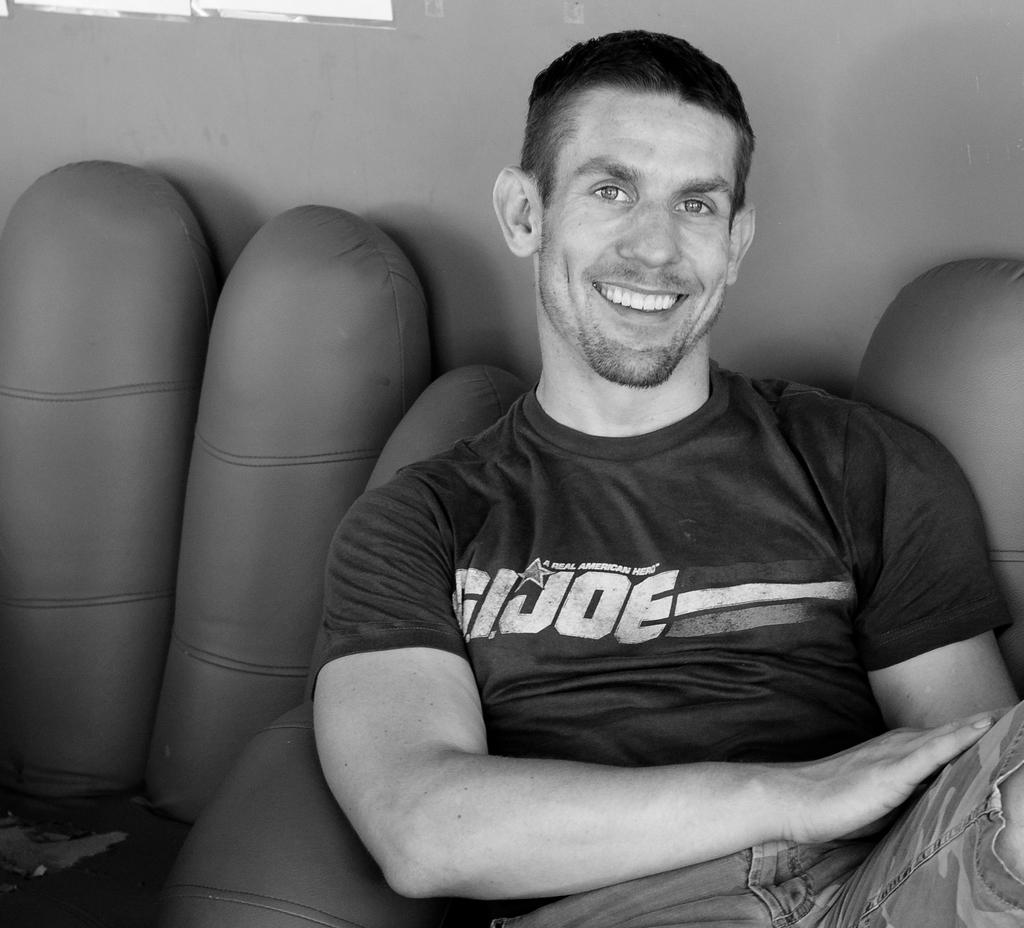What is the color scheme of the image? The image is black and white. Who is present in the image? There is a man in the image. What type of clothing is the man wearing? The man is wearing a t-shirt and jeans. Where is the man located in the image? The man is sitting in front of a wall. What pin is the man using to hold his idea in the image? There is no pin or idea present in the image; it only features a man sitting in front of a wall. 